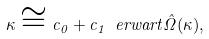<formula> <loc_0><loc_0><loc_500><loc_500>\kappa \cong c _ { 0 } + c _ { 1 } \ e r w a r t { \hat { \Omega } } ( \kappa ) ,</formula> 